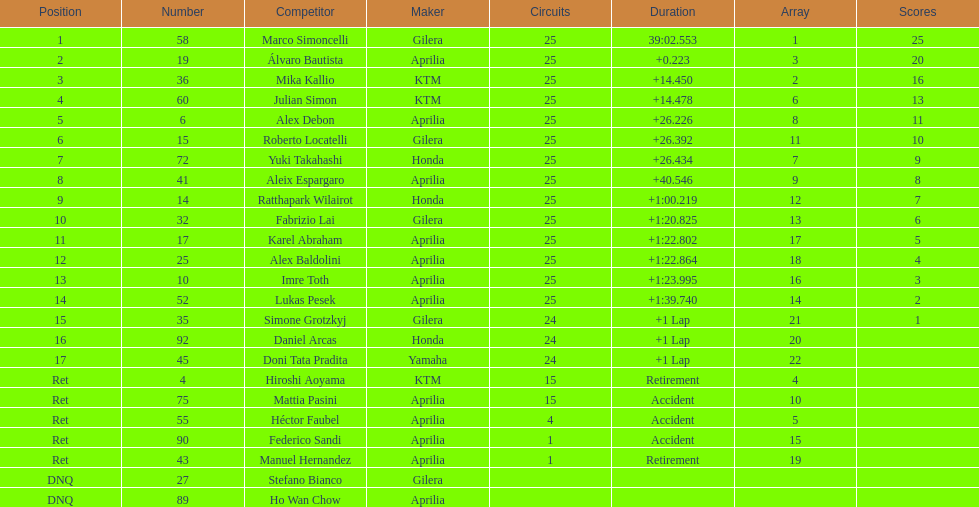Who were all of the riders? Marco Simoncelli, Álvaro Bautista, Mika Kallio, Julian Simon, Alex Debon, Roberto Locatelli, Yuki Takahashi, Aleix Espargaro, Ratthapark Wilairot, Fabrizio Lai, Karel Abraham, Alex Baldolini, Imre Toth, Lukas Pesek, Simone Grotzkyj, Daniel Arcas, Doni Tata Pradita, Hiroshi Aoyama, Mattia Pasini, Héctor Faubel, Federico Sandi, Manuel Hernandez, Stefano Bianco, Ho Wan Chow. How many laps did they complete? 25, 25, 25, 25, 25, 25, 25, 25, 25, 25, 25, 25, 25, 25, 24, 24, 24, 15, 15, 4, 1, 1, , . Between marco simoncelli and hiroshi aoyama, who had more laps? Marco Simoncelli. 